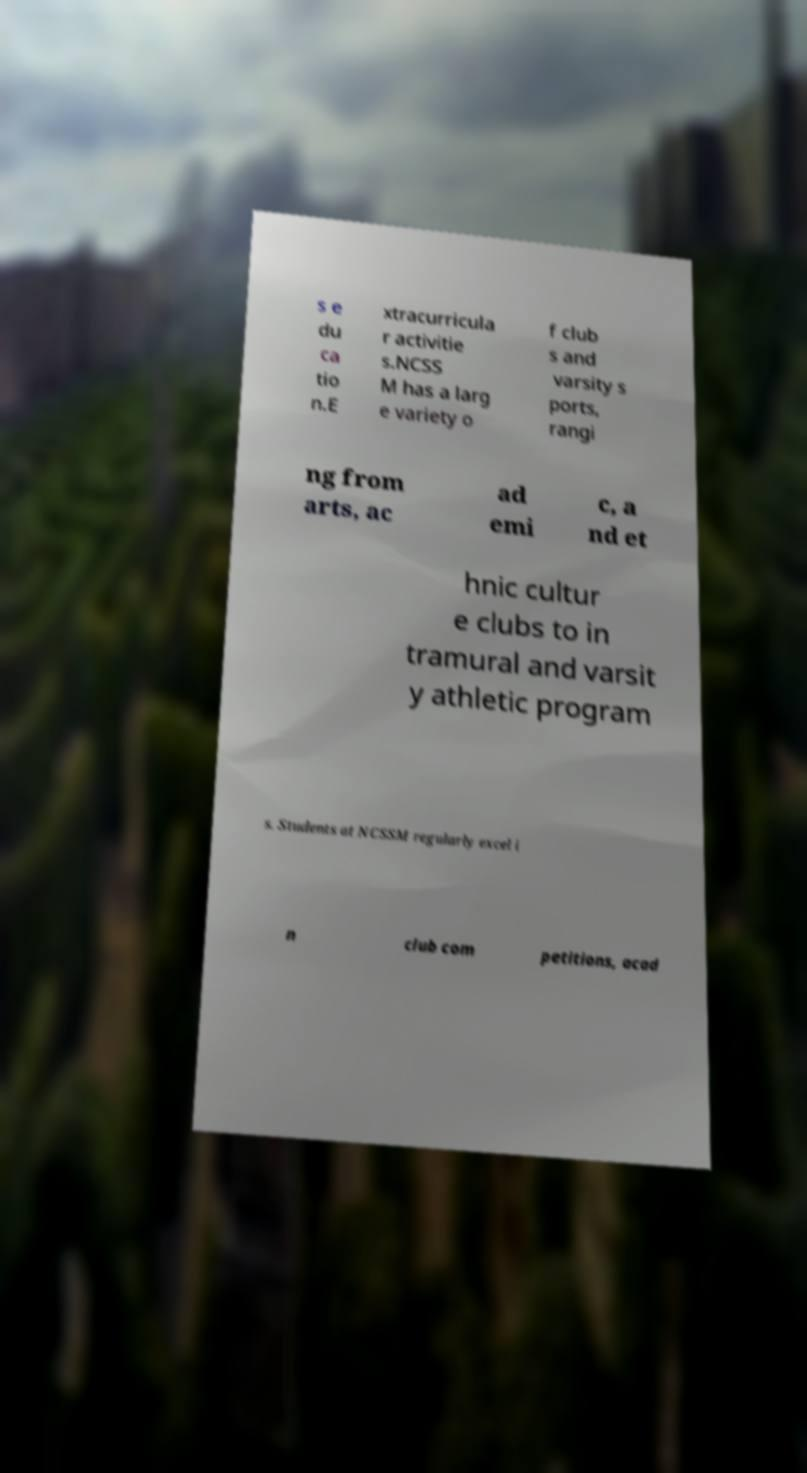For documentation purposes, I need the text within this image transcribed. Could you provide that? s e du ca tio n.E xtracurricula r activitie s.NCSS M has a larg e variety o f club s and varsity s ports, rangi ng from arts, ac ad emi c, a nd et hnic cultur e clubs to in tramural and varsit y athletic program s. Students at NCSSM regularly excel i n club com petitions, acad 